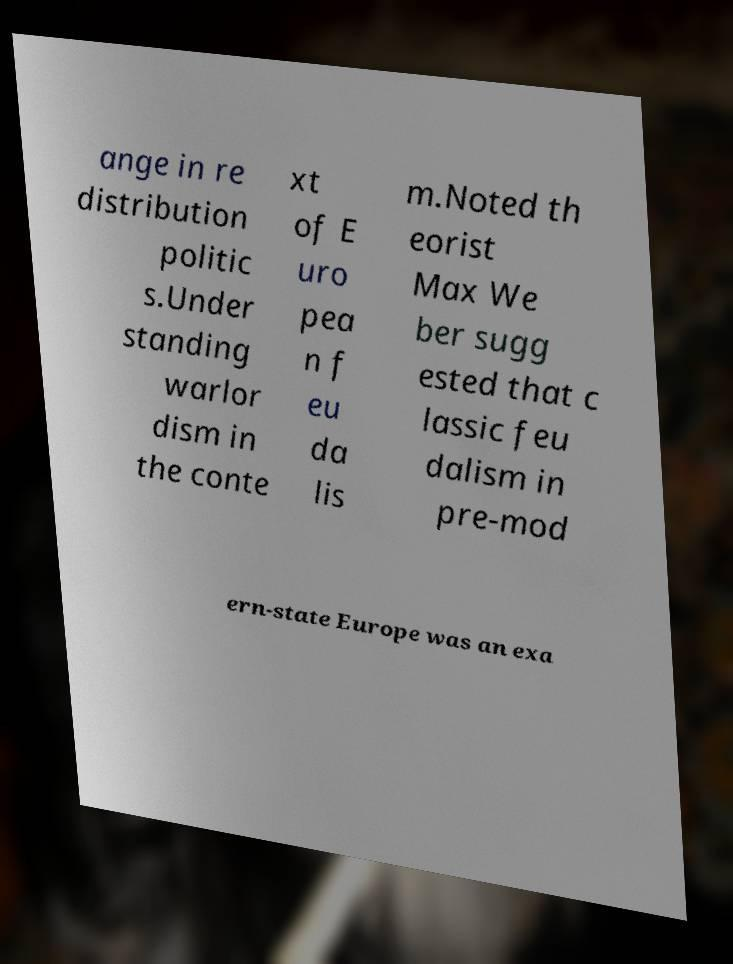Could you assist in decoding the text presented in this image and type it out clearly? ange in re distribution politic s.Under standing warlor dism in the conte xt of E uro pea n f eu da lis m.Noted th eorist Max We ber sugg ested that c lassic feu dalism in pre-mod ern-state Europe was an exa 